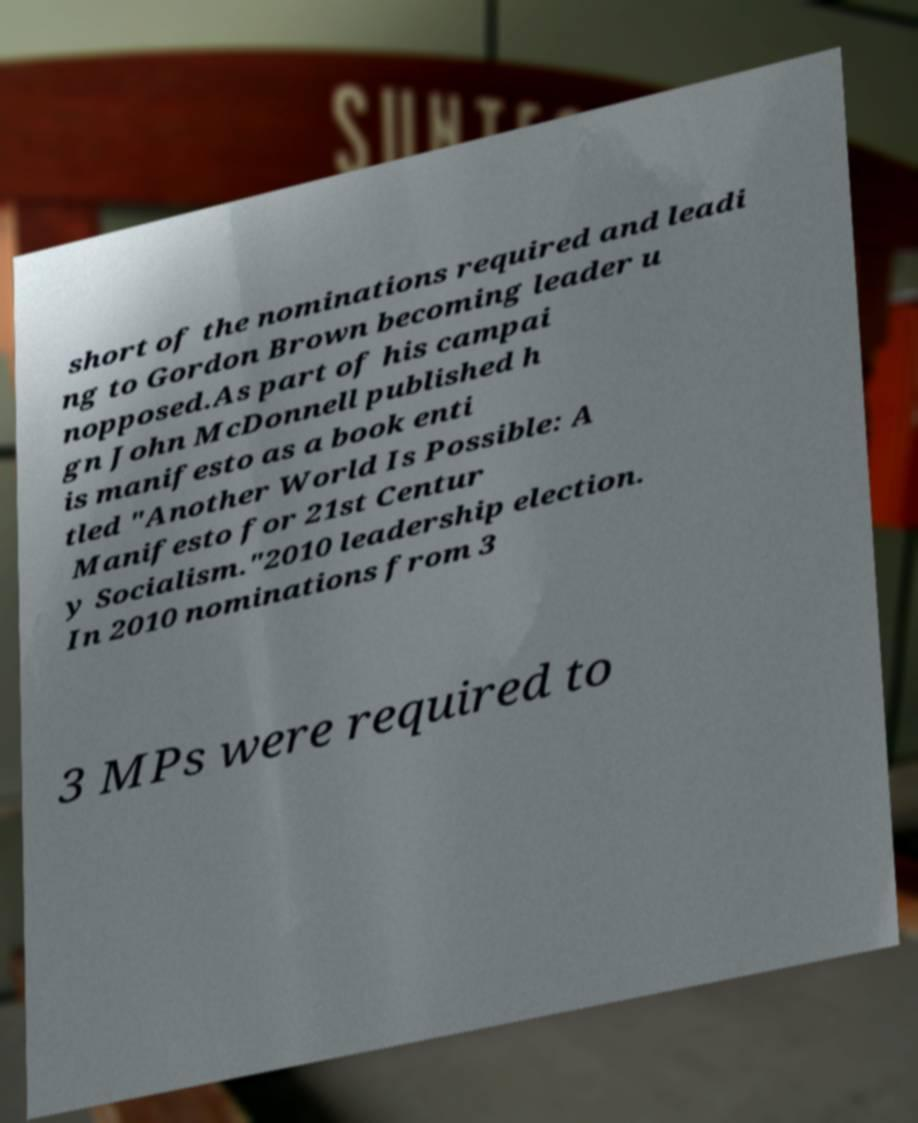Please read and relay the text visible in this image. What does it say? short of the nominations required and leadi ng to Gordon Brown becoming leader u nopposed.As part of his campai gn John McDonnell published h is manifesto as a book enti tled "Another World Is Possible: A Manifesto for 21st Centur y Socialism."2010 leadership election. In 2010 nominations from 3 3 MPs were required to 